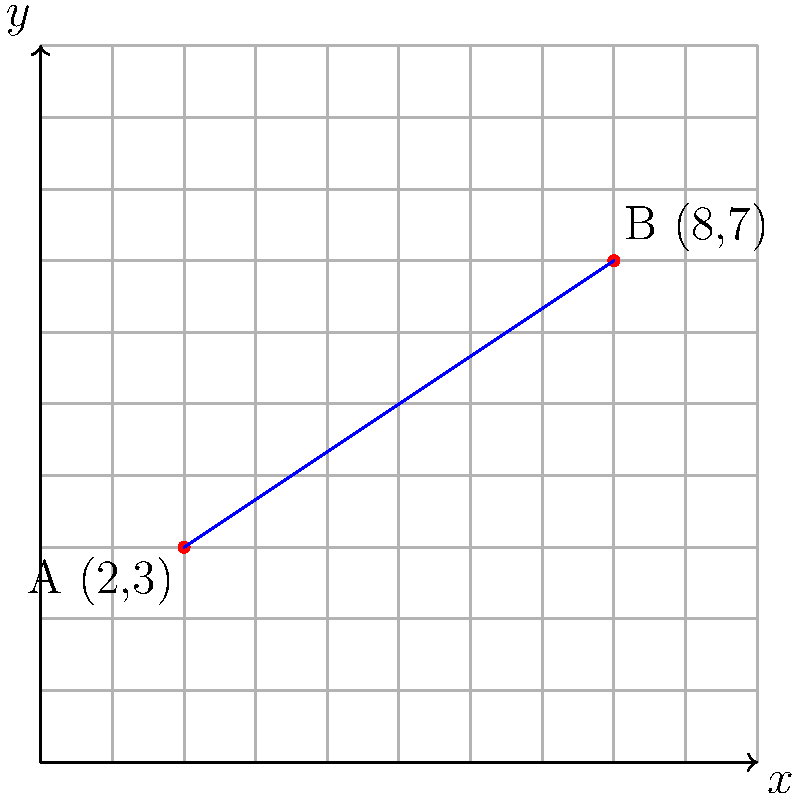Robinsons Retail is planning to optimize its delivery routes between two store locations in Metro Manila. Store A is located at coordinates (2,3) and Store B is at (8,7) on a grid where each unit represents 1 kilometer. What is the shortest distance, in kilometers, between these two stores? To find the shortest distance between two points on a 2D grid, we can use the distance formula derived from the Pythagorean theorem:

$$ d = \sqrt{(x_2 - x_1)^2 + (y_2 - y_1)^2} $$

Where $(x_1, y_1)$ are the coordinates of the first point and $(x_2, y_2)$ are the coordinates of the second point.

Given:
- Store A: $(x_1, y_1) = (2, 3)$
- Store B: $(x_2, y_2) = (8, 7)$

Let's plug these values into the formula:

$$ d = \sqrt{(8 - 2)^2 + (7 - 3)^2} $$

Simplify:
$$ d = \sqrt{6^2 + 4^2} $$

Calculate the squares:
$$ d = \sqrt{36 + 16} $$

Add under the square root:
$$ d = \sqrt{52} $$

Simplify the square root:
$$ d = 2\sqrt{13} $$

Since each unit represents 1 kilometer, the shortest distance between the two Robinsons Retail stores is $2\sqrt{13}$ kilometers.
Answer: $2\sqrt{13}$ km 